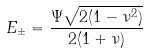<formula> <loc_0><loc_0><loc_500><loc_500>E _ { \pm } = \frac { \Psi \sqrt { 2 ( 1 - \nu ^ { 2 } ) } } { 2 ( 1 + \nu ) }</formula> 